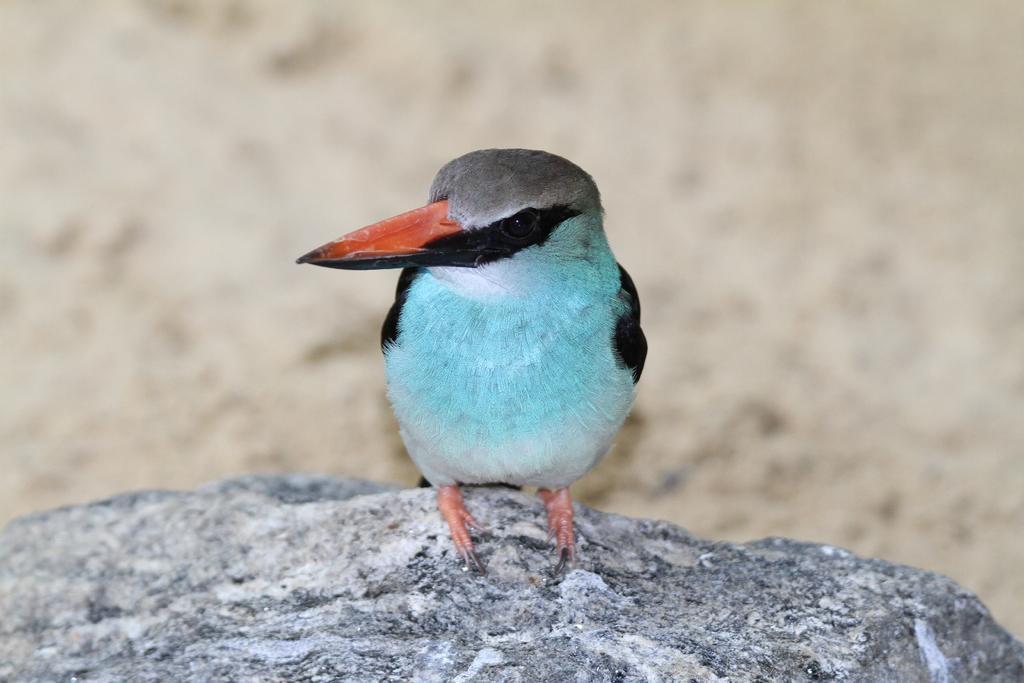Can you describe this image briefly? In the center of the image we can see a bird on the rock. 